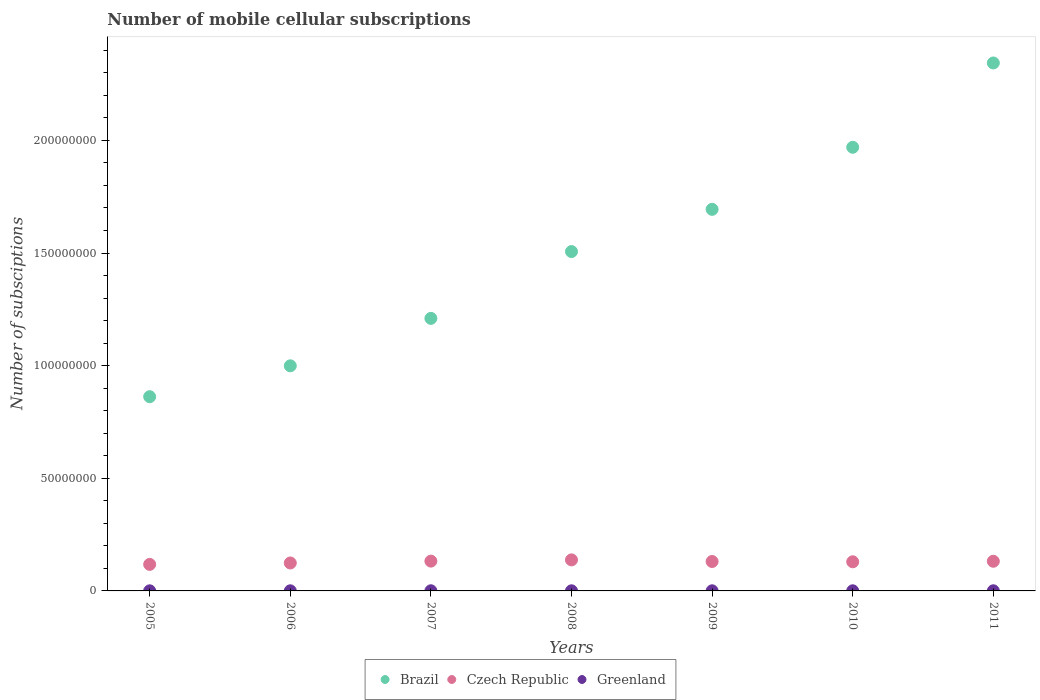How many different coloured dotlines are there?
Keep it short and to the point. 3. What is the number of mobile cellular subscriptions in Czech Republic in 2007?
Keep it short and to the point. 1.32e+07. Across all years, what is the maximum number of mobile cellular subscriptions in Czech Republic?
Your answer should be very brief. 1.38e+07. Across all years, what is the minimum number of mobile cellular subscriptions in Greenland?
Your answer should be compact. 4.65e+04. In which year was the number of mobile cellular subscriptions in Brazil maximum?
Offer a terse response. 2011. What is the total number of mobile cellular subscriptions in Greenland in the graph?
Your answer should be compact. 3.92e+05. What is the difference between the number of mobile cellular subscriptions in Czech Republic in 2006 and that in 2007?
Ensure brevity in your answer.  -8.22e+05. What is the difference between the number of mobile cellular subscriptions in Brazil in 2010 and the number of mobile cellular subscriptions in Czech Republic in 2009?
Your answer should be very brief. 1.84e+08. What is the average number of mobile cellular subscriptions in Czech Republic per year?
Your response must be concise. 1.29e+07. In the year 2007, what is the difference between the number of mobile cellular subscriptions in Greenland and number of mobile cellular subscriptions in Brazil?
Give a very brief answer. -1.21e+08. What is the ratio of the number of mobile cellular subscriptions in Greenland in 2005 to that in 2011?
Provide a short and direct response. 0.79. Is the number of mobile cellular subscriptions in Czech Republic in 2007 less than that in 2010?
Provide a short and direct response. No. What is the difference between the highest and the second highest number of mobile cellular subscriptions in Brazil?
Your answer should be compact. 3.74e+07. What is the difference between the highest and the lowest number of mobile cellular subscriptions in Czech Republic?
Your answer should be very brief. 2.00e+06. Does the number of mobile cellular subscriptions in Czech Republic monotonically increase over the years?
Provide a succinct answer. No. Is the number of mobile cellular subscriptions in Brazil strictly less than the number of mobile cellular subscriptions in Greenland over the years?
Ensure brevity in your answer.  No. How many dotlines are there?
Offer a terse response. 3. How many years are there in the graph?
Provide a short and direct response. 7. Where does the legend appear in the graph?
Offer a terse response. Bottom center. How many legend labels are there?
Provide a succinct answer. 3. What is the title of the graph?
Ensure brevity in your answer.  Number of mobile cellular subscriptions. What is the label or title of the Y-axis?
Provide a succinct answer. Number of subsciptions. What is the Number of subsciptions of Brazil in 2005?
Offer a terse response. 8.62e+07. What is the Number of subsciptions in Czech Republic in 2005?
Keep it short and to the point. 1.18e+07. What is the Number of subsciptions of Greenland in 2005?
Provide a succinct answer. 4.65e+04. What is the Number of subsciptions in Brazil in 2006?
Keep it short and to the point. 9.99e+07. What is the Number of subsciptions of Czech Republic in 2006?
Your answer should be compact. 1.24e+07. What is the Number of subsciptions of Greenland in 2006?
Provide a short and direct response. 5.39e+04. What is the Number of subsciptions of Brazil in 2007?
Offer a very short reply. 1.21e+08. What is the Number of subsciptions of Czech Republic in 2007?
Keep it short and to the point. 1.32e+07. What is the Number of subsciptions of Greenland in 2007?
Keep it short and to the point. 6.64e+04. What is the Number of subsciptions of Brazil in 2008?
Your answer should be compact. 1.51e+08. What is the Number of subsciptions of Czech Republic in 2008?
Make the answer very short. 1.38e+07. What is the Number of subsciptions in Greenland in 2008?
Keep it short and to the point. 5.58e+04. What is the Number of subsciptions in Brazil in 2009?
Your answer should be very brief. 1.69e+08. What is the Number of subsciptions in Czech Republic in 2009?
Ensure brevity in your answer.  1.31e+07. What is the Number of subsciptions of Greenland in 2009?
Your response must be concise. 5.35e+04. What is the Number of subsciptions in Brazil in 2010?
Your response must be concise. 1.97e+08. What is the Number of subsciptions of Czech Republic in 2010?
Your answer should be compact. 1.29e+07. What is the Number of subsciptions in Greenland in 2010?
Offer a very short reply. 5.73e+04. What is the Number of subsciptions of Brazil in 2011?
Give a very brief answer. 2.34e+08. What is the Number of subsciptions in Czech Republic in 2011?
Make the answer very short. 1.32e+07. What is the Number of subsciptions in Greenland in 2011?
Provide a succinct answer. 5.87e+04. Across all years, what is the maximum Number of subsciptions of Brazil?
Your response must be concise. 2.34e+08. Across all years, what is the maximum Number of subsciptions of Czech Republic?
Your answer should be compact. 1.38e+07. Across all years, what is the maximum Number of subsciptions of Greenland?
Give a very brief answer. 6.64e+04. Across all years, what is the minimum Number of subsciptions of Brazil?
Your response must be concise. 8.62e+07. Across all years, what is the minimum Number of subsciptions in Czech Republic?
Your response must be concise. 1.18e+07. Across all years, what is the minimum Number of subsciptions in Greenland?
Your response must be concise. 4.65e+04. What is the total Number of subsciptions in Brazil in the graph?
Offer a very short reply. 1.06e+09. What is the total Number of subsciptions of Czech Republic in the graph?
Give a very brief answer. 9.04e+07. What is the total Number of subsciptions of Greenland in the graph?
Your response must be concise. 3.92e+05. What is the difference between the Number of subsciptions of Brazil in 2005 and that in 2006?
Your answer should be very brief. -1.37e+07. What is the difference between the Number of subsciptions in Czech Republic in 2005 and that in 2006?
Offer a terse response. -6.30e+05. What is the difference between the Number of subsciptions in Greenland in 2005 and that in 2006?
Your response must be concise. -7420. What is the difference between the Number of subsciptions in Brazil in 2005 and that in 2007?
Provide a succinct answer. -3.48e+07. What is the difference between the Number of subsciptions in Czech Republic in 2005 and that in 2007?
Provide a short and direct response. -1.45e+06. What is the difference between the Number of subsciptions in Greenland in 2005 and that in 2007?
Your response must be concise. -1.99e+04. What is the difference between the Number of subsciptions of Brazil in 2005 and that in 2008?
Ensure brevity in your answer.  -6.44e+07. What is the difference between the Number of subsciptions of Czech Republic in 2005 and that in 2008?
Make the answer very short. -2.00e+06. What is the difference between the Number of subsciptions of Greenland in 2005 and that in 2008?
Keep it short and to the point. -9336. What is the difference between the Number of subsciptions of Brazil in 2005 and that in 2009?
Offer a terse response. -8.32e+07. What is the difference between the Number of subsciptions in Czech Republic in 2005 and that in 2009?
Ensure brevity in your answer.  -1.29e+06. What is the difference between the Number of subsciptions of Greenland in 2005 and that in 2009?
Your response must be concise. -6988. What is the difference between the Number of subsciptions in Brazil in 2005 and that in 2010?
Your answer should be very brief. -1.11e+08. What is the difference between the Number of subsciptions in Czech Republic in 2005 and that in 2010?
Make the answer very short. -1.16e+06. What is the difference between the Number of subsciptions in Greenland in 2005 and that in 2010?
Ensure brevity in your answer.  -1.09e+04. What is the difference between the Number of subsciptions in Brazil in 2005 and that in 2011?
Make the answer very short. -1.48e+08. What is the difference between the Number of subsciptions of Czech Republic in 2005 and that in 2011?
Make the answer very short. -1.39e+06. What is the difference between the Number of subsciptions in Greenland in 2005 and that in 2011?
Ensure brevity in your answer.  -1.23e+04. What is the difference between the Number of subsciptions of Brazil in 2006 and that in 2007?
Your answer should be very brief. -2.11e+07. What is the difference between the Number of subsciptions of Czech Republic in 2006 and that in 2007?
Your answer should be compact. -8.22e+05. What is the difference between the Number of subsciptions in Greenland in 2006 and that in 2007?
Offer a very short reply. -1.25e+04. What is the difference between the Number of subsciptions in Brazil in 2006 and that in 2008?
Give a very brief answer. -5.07e+07. What is the difference between the Number of subsciptions in Czech Republic in 2006 and that in 2008?
Give a very brief answer. -1.37e+06. What is the difference between the Number of subsciptions of Greenland in 2006 and that in 2008?
Your answer should be very brief. -1916. What is the difference between the Number of subsciptions of Brazil in 2006 and that in 2009?
Offer a very short reply. -6.95e+07. What is the difference between the Number of subsciptions of Czech Republic in 2006 and that in 2009?
Provide a short and direct response. -6.56e+05. What is the difference between the Number of subsciptions of Greenland in 2006 and that in 2009?
Keep it short and to the point. 432. What is the difference between the Number of subsciptions of Brazil in 2006 and that in 2010?
Keep it short and to the point. -9.70e+07. What is the difference between the Number of subsciptions of Czech Republic in 2006 and that in 2010?
Your answer should be very brief. -5.28e+05. What is the difference between the Number of subsciptions of Greenland in 2006 and that in 2010?
Offer a very short reply. -3449. What is the difference between the Number of subsciptions in Brazil in 2006 and that in 2011?
Give a very brief answer. -1.34e+08. What is the difference between the Number of subsciptions in Czech Republic in 2006 and that in 2011?
Give a very brief answer. -7.62e+05. What is the difference between the Number of subsciptions of Greenland in 2006 and that in 2011?
Offer a very short reply. -4842. What is the difference between the Number of subsciptions of Brazil in 2007 and that in 2008?
Offer a terse response. -2.97e+07. What is the difference between the Number of subsciptions in Czech Republic in 2007 and that in 2008?
Make the answer very short. -5.52e+05. What is the difference between the Number of subsciptions in Greenland in 2007 and that in 2008?
Offer a terse response. 1.06e+04. What is the difference between the Number of subsciptions in Brazil in 2007 and that in 2009?
Provide a succinct answer. -4.84e+07. What is the difference between the Number of subsciptions of Czech Republic in 2007 and that in 2009?
Your response must be concise. 1.66e+05. What is the difference between the Number of subsciptions in Greenland in 2007 and that in 2009?
Your response must be concise. 1.29e+04. What is the difference between the Number of subsciptions of Brazil in 2007 and that in 2010?
Offer a very short reply. -7.59e+07. What is the difference between the Number of subsciptions in Czech Republic in 2007 and that in 2010?
Provide a succinct answer. 2.95e+05. What is the difference between the Number of subsciptions of Greenland in 2007 and that in 2010?
Your response must be concise. 9051. What is the difference between the Number of subsciptions of Brazil in 2007 and that in 2011?
Keep it short and to the point. -1.13e+08. What is the difference between the Number of subsciptions in Czech Republic in 2007 and that in 2011?
Ensure brevity in your answer.  6.09e+04. What is the difference between the Number of subsciptions of Greenland in 2007 and that in 2011?
Offer a very short reply. 7658. What is the difference between the Number of subsciptions in Brazil in 2008 and that in 2009?
Offer a terse response. -1.87e+07. What is the difference between the Number of subsciptions of Czech Republic in 2008 and that in 2009?
Ensure brevity in your answer.  7.18e+05. What is the difference between the Number of subsciptions in Greenland in 2008 and that in 2009?
Offer a terse response. 2348. What is the difference between the Number of subsciptions of Brazil in 2008 and that in 2010?
Offer a terse response. -4.63e+07. What is the difference between the Number of subsciptions of Czech Republic in 2008 and that in 2010?
Provide a short and direct response. 8.46e+05. What is the difference between the Number of subsciptions of Greenland in 2008 and that in 2010?
Your answer should be very brief. -1533. What is the difference between the Number of subsciptions of Brazil in 2008 and that in 2011?
Offer a terse response. -8.37e+07. What is the difference between the Number of subsciptions in Czech Republic in 2008 and that in 2011?
Make the answer very short. 6.12e+05. What is the difference between the Number of subsciptions of Greenland in 2008 and that in 2011?
Give a very brief answer. -2926. What is the difference between the Number of subsciptions of Brazil in 2009 and that in 2010?
Your answer should be very brief. -2.75e+07. What is the difference between the Number of subsciptions in Czech Republic in 2009 and that in 2010?
Your answer should be very brief. 1.29e+05. What is the difference between the Number of subsciptions in Greenland in 2009 and that in 2010?
Your answer should be compact. -3881. What is the difference between the Number of subsciptions of Brazil in 2009 and that in 2011?
Make the answer very short. -6.50e+07. What is the difference between the Number of subsciptions in Czech Republic in 2009 and that in 2011?
Give a very brief answer. -1.05e+05. What is the difference between the Number of subsciptions in Greenland in 2009 and that in 2011?
Ensure brevity in your answer.  -5274. What is the difference between the Number of subsciptions in Brazil in 2010 and that in 2011?
Your response must be concise. -3.74e+07. What is the difference between the Number of subsciptions in Czech Republic in 2010 and that in 2011?
Your answer should be very brief. -2.34e+05. What is the difference between the Number of subsciptions of Greenland in 2010 and that in 2011?
Your answer should be very brief. -1393. What is the difference between the Number of subsciptions of Brazil in 2005 and the Number of subsciptions of Czech Republic in 2006?
Keep it short and to the point. 7.38e+07. What is the difference between the Number of subsciptions in Brazil in 2005 and the Number of subsciptions in Greenland in 2006?
Offer a terse response. 8.62e+07. What is the difference between the Number of subsciptions of Czech Republic in 2005 and the Number of subsciptions of Greenland in 2006?
Your answer should be compact. 1.17e+07. What is the difference between the Number of subsciptions in Brazil in 2005 and the Number of subsciptions in Czech Republic in 2007?
Your answer should be very brief. 7.30e+07. What is the difference between the Number of subsciptions of Brazil in 2005 and the Number of subsciptions of Greenland in 2007?
Make the answer very short. 8.61e+07. What is the difference between the Number of subsciptions in Czech Republic in 2005 and the Number of subsciptions in Greenland in 2007?
Keep it short and to the point. 1.17e+07. What is the difference between the Number of subsciptions in Brazil in 2005 and the Number of subsciptions in Czech Republic in 2008?
Provide a succinct answer. 7.24e+07. What is the difference between the Number of subsciptions in Brazil in 2005 and the Number of subsciptions in Greenland in 2008?
Your answer should be compact. 8.62e+07. What is the difference between the Number of subsciptions in Czech Republic in 2005 and the Number of subsciptions in Greenland in 2008?
Your response must be concise. 1.17e+07. What is the difference between the Number of subsciptions in Brazil in 2005 and the Number of subsciptions in Czech Republic in 2009?
Give a very brief answer. 7.31e+07. What is the difference between the Number of subsciptions of Brazil in 2005 and the Number of subsciptions of Greenland in 2009?
Offer a terse response. 8.62e+07. What is the difference between the Number of subsciptions in Czech Republic in 2005 and the Number of subsciptions in Greenland in 2009?
Ensure brevity in your answer.  1.17e+07. What is the difference between the Number of subsciptions of Brazil in 2005 and the Number of subsciptions of Czech Republic in 2010?
Keep it short and to the point. 7.33e+07. What is the difference between the Number of subsciptions of Brazil in 2005 and the Number of subsciptions of Greenland in 2010?
Your answer should be very brief. 8.62e+07. What is the difference between the Number of subsciptions in Czech Republic in 2005 and the Number of subsciptions in Greenland in 2010?
Make the answer very short. 1.17e+07. What is the difference between the Number of subsciptions of Brazil in 2005 and the Number of subsciptions of Czech Republic in 2011?
Make the answer very short. 7.30e+07. What is the difference between the Number of subsciptions of Brazil in 2005 and the Number of subsciptions of Greenland in 2011?
Give a very brief answer. 8.62e+07. What is the difference between the Number of subsciptions of Czech Republic in 2005 and the Number of subsciptions of Greenland in 2011?
Offer a terse response. 1.17e+07. What is the difference between the Number of subsciptions in Brazil in 2006 and the Number of subsciptions in Czech Republic in 2007?
Your answer should be compact. 8.67e+07. What is the difference between the Number of subsciptions of Brazil in 2006 and the Number of subsciptions of Greenland in 2007?
Offer a very short reply. 9.99e+07. What is the difference between the Number of subsciptions of Czech Republic in 2006 and the Number of subsciptions of Greenland in 2007?
Ensure brevity in your answer.  1.23e+07. What is the difference between the Number of subsciptions in Brazil in 2006 and the Number of subsciptions in Czech Republic in 2008?
Your response must be concise. 8.61e+07. What is the difference between the Number of subsciptions in Brazil in 2006 and the Number of subsciptions in Greenland in 2008?
Your response must be concise. 9.99e+07. What is the difference between the Number of subsciptions of Czech Republic in 2006 and the Number of subsciptions of Greenland in 2008?
Keep it short and to the point. 1.24e+07. What is the difference between the Number of subsciptions of Brazil in 2006 and the Number of subsciptions of Czech Republic in 2009?
Keep it short and to the point. 8.69e+07. What is the difference between the Number of subsciptions of Brazil in 2006 and the Number of subsciptions of Greenland in 2009?
Offer a very short reply. 9.99e+07. What is the difference between the Number of subsciptions in Czech Republic in 2006 and the Number of subsciptions in Greenland in 2009?
Keep it short and to the point. 1.24e+07. What is the difference between the Number of subsciptions of Brazil in 2006 and the Number of subsciptions of Czech Republic in 2010?
Provide a short and direct response. 8.70e+07. What is the difference between the Number of subsciptions in Brazil in 2006 and the Number of subsciptions in Greenland in 2010?
Offer a terse response. 9.99e+07. What is the difference between the Number of subsciptions in Czech Republic in 2006 and the Number of subsciptions in Greenland in 2010?
Ensure brevity in your answer.  1.23e+07. What is the difference between the Number of subsciptions in Brazil in 2006 and the Number of subsciptions in Czech Republic in 2011?
Your answer should be very brief. 8.68e+07. What is the difference between the Number of subsciptions of Brazil in 2006 and the Number of subsciptions of Greenland in 2011?
Ensure brevity in your answer.  9.99e+07. What is the difference between the Number of subsciptions of Czech Republic in 2006 and the Number of subsciptions of Greenland in 2011?
Provide a short and direct response. 1.23e+07. What is the difference between the Number of subsciptions of Brazil in 2007 and the Number of subsciptions of Czech Republic in 2008?
Offer a terse response. 1.07e+08. What is the difference between the Number of subsciptions in Brazil in 2007 and the Number of subsciptions in Greenland in 2008?
Your answer should be compact. 1.21e+08. What is the difference between the Number of subsciptions in Czech Republic in 2007 and the Number of subsciptions in Greenland in 2008?
Keep it short and to the point. 1.32e+07. What is the difference between the Number of subsciptions in Brazil in 2007 and the Number of subsciptions in Czech Republic in 2009?
Your answer should be compact. 1.08e+08. What is the difference between the Number of subsciptions of Brazil in 2007 and the Number of subsciptions of Greenland in 2009?
Your answer should be compact. 1.21e+08. What is the difference between the Number of subsciptions in Czech Republic in 2007 and the Number of subsciptions in Greenland in 2009?
Your answer should be compact. 1.32e+07. What is the difference between the Number of subsciptions of Brazil in 2007 and the Number of subsciptions of Czech Republic in 2010?
Offer a terse response. 1.08e+08. What is the difference between the Number of subsciptions in Brazil in 2007 and the Number of subsciptions in Greenland in 2010?
Provide a succinct answer. 1.21e+08. What is the difference between the Number of subsciptions in Czech Republic in 2007 and the Number of subsciptions in Greenland in 2010?
Offer a terse response. 1.32e+07. What is the difference between the Number of subsciptions of Brazil in 2007 and the Number of subsciptions of Czech Republic in 2011?
Ensure brevity in your answer.  1.08e+08. What is the difference between the Number of subsciptions of Brazil in 2007 and the Number of subsciptions of Greenland in 2011?
Give a very brief answer. 1.21e+08. What is the difference between the Number of subsciptions of Czech Republic in 2007 and the Number of subsciptions of Greenland in 2011?
Keep it short and to the point. 1.32e+07. What is the difference between the Number of subsciptions in Brazil in 2008 and the Number of subsciptions in Czech Republic in 2009?
Your answer should be very brief. 1.38e+08. What is the difference between the Number of subsciptions in Brazil in 2008 and the Number of subsciptions in Greenland in 2009?
Make the answer very short. 1.51e+08. What is the difference between the Number of subsciptions in Czech Republic in 2008 and the Number of subsciptions in Greenland in 2009?
Your answer should be compact. 1.37e+07. What is the difference between the Number of subsciptions in Brazil in 2008 and the Number of subsciptions in Czech Republic in 2010?
Offer a very short reply. 1.38e+08. What is the difference between the Number of subsciptions in Brazil in 2008 and the Number of subsciptions in Greenland in 2010?
Keep it short and to the point. 1.51e+08. What is the difference between the Number of subsciptions in Czech Republic in 2008 and the Number of subsciptions in Greenland in 2010?
Provide a succinct answer. 1.37e+07. What is the difference between the Number of subsciptions in Brazil in 2008 and the Number of subsciptions in Czech Republic in 2011?
Provide a short and direct response. 1.37e+08. What is the difference between the Number of subsciptions of Brazil in 2008 and the Number of subsciptions of Greenland in 2011?
Provide a short and direct response. 1.51e+08. What is the difference between the Number of subsciptions in Czech Republic in 2008 and the Number of subsciptions in Greenland in 2011?
Ensure brevity in your answer.  1.37e+07. What is the difference between the Number of subsciptions of Brazil in 2009 and the Number of subsciptions of Czech Republic in 2010?
Keep it short and to the point. 1.56e+08. What is the difference between the Number of subsciptions of Brazil in 2009 and the Number of subsciptions of Greenland in 2010?
Your response must be concise. 1.69e+08. What is the difference between the Number of subsciptions in Czech Republic in 2009 and the Number of subsciptions in Greenland in 2010?
Offer a terse response. 1.30e+07. What is the difference between the Number of subsciptions in Brazil in 2009 and the Number of subsciptions in Czech Republic in 2011?
Your answer should be very brief. 1.56e+08. What is the difference between the Number of subsciptions in Brazil in 2009 and the Number of subsciptions in Greenland in 2011?
Keep it short and to the point. 1.69e+08. What is the difference between the Number of subsciptions of Czech Republic in 2009 and the Number of subsciptions of Greenland in 2011?
Provide a short and direct response. 1.30e+07. What is the difference between the Number of subsciptions of Brazil in 2010 and the Number of subsciptions of Czech Republic in 2011?
Keep it short and to the point. 1.84e+08. What is the difference between the Number of subsciptions in Brazil in 2010 and the Number of subsciptions in Greenland in 2011?
Your answer should be compact. 1.97e+08. What is the difference between the Number of subsciptions of Czech Republic in 2010 and the Number of subsciptions of Greenland in 2011?
Your response must be concise. 1.29e+07. What is the average Number of subsciptions in Brazil per year?
Offer a terse response. 1.51e+08. What is the average Number of subsciptions in Czech Republic per year?
Your answer should be compact. 1.29e+07. What is the average Number of subsciptions in Greenland per year?
Your answer should be compact. 5.60e+04. In the year 2005, what is the difference between the Number of subsciptions of Brazil and Number of subsciptions of Czech Republic?
Your answer should be compact. 7.44e+07. In the year 2005, what is the difference between the Number of subsciptions of Brazil and Number of subsciptions of Greenland?
Give a very brief answer. 8.62e+07. In the year 2005, what is the difference between the Number of subsciptions of Czech Republic and Number of subsciptions of Greenland?
Provide a short and direct response. 1.17e+07. In the year 2006, what is the difference between the Number of subsciptions in Brazil and Number of subsciptions in Czech Republic?
Offer a terse response. 8.75e+07. In the year 2006, what is the difference between the Number of subsciptions of Brazil and Number of subsciptions of Greenland?
Your answer should be very brief. 9.99e+07. In the year 2006, what is the difference between the Number of subsciptions of Czech Republic and Number of subsciptions of Greenland?
Keep it short and to the point. 1.24e+07. In the year 2007, what is the difference between the Number of subsciptions of Brazil and Number of subsciptions of Czech Republic?
Offer a terse response. 1.08e+08. In the year 2007, what is the difference between the Number of subsciptions in Brazil and Number of subsciptions in Greenland?
Keep it short and to the point. 1.21e+08. In the year 2007, what is the difference between the Number of subsciptions in Czech Republic and Number of subsciptions in Greenland?
Provide a short and direct response. 1.32e+07. In the year 2008, what is the difference between the Number of subsciptions in Brazil and Number of subsciptions in Czech Republic?
Your response must be concise. 1.37e+08. In the year 2008, what is the difference between the Number of subsciptions of Brazil and Number of subsciptions of Greenland?
Offer a terse response. 1.51e+08. In the year 2008, what is the difference between the Number of subsciptions of Czech Republic and Number of subsciptions of Greenland?
Your answer should be very brief. 1.37e+07. In the year 2009, what is the difference between the Number of subsciptions of Brazil and Number of subsciptions of Czech Republic?
Keep it short and to the point. 1.56e+08. In the year 2009, what is the difference between the Number of subsciptions in Brazil and Number of subsciptions in Greenland?
Give a very brief answer. 1.69e+08. In the year 2009, what is the difference between the Number of subsciptions of Czech Republic and Number of subsciptions of Greenland?
Provide a succinct answer. 1.30e+07. In the year 2010, what is the difference between the Number of subsciptions in Brazil and Number of subsciptions in Czech Republic?
Keep it short and to the point. 1.84e+08. In the year 2010, what is the difference between the Number of subsciptions in Brazil and Number of subsciptions in Greenland?
Give a very brief answer. 1.97e+08. In the year 2010, what is the difference between the Number of subsciptions of Czech Republic and Number of subsciptions of Greenland?
Offer a very short reply. 1.29e+07. In the year 2011, what is the difference between the Number of subsciptions in Brazil and Number of subsciptions in Czech Republic?
Ensure brevity in your answer.  2.21e+08. In the year 2011, what is the difference between the Number of subsciptions of Brazil and Number of subsciptions of Greenland?
Your response must be concise. 2.34e+08. In the year 2011, what is the difference between the Number of subsciptions in Czech Republic and Number of subsciptions in Greenland?
Provide a short and direct response. 1.31e+07. What is the ratio of the Number of subsciptions in Brazil in 2005 to that in 2006?
Offer a very short reply. 0.86. What is the ratio of the Number of subsciptions in Czech Republic in 2005 to that in 2006?
Your answer should be compact. 0.95. What is the ratio of the Number of subsciptions of Greenland in 2005 to that in 2006?
Offer a terse response. 0.86. What is the ratio of the Number of subsciptions of Brazil in 2005 to that in 2007?
Keep it short and to the point. 0.71. What is the ratio of the Number of subsciptions of Czech Republic in 2005 to that in 2007?
Your answer should be very brief. 0.89. What is the ratio of the Number of subsciptions in Greenland in 2005 to that in 2007?
Provide a succinct answer. 0.7. What is the ratio of the Number of subsciptions of Brazil in 2005 to that in 2008?
Provide a succinct answer. 0.57. What is the ratio of the Number of subsciptions in Czech Republic in 2005 to that in 2008?
Provide a short and direct response. 0.85. What is the ratio of the Number of subsciptions of Greenland in 2005 to that in 2008?
Offer a terse response. 0.83. What is the ratio of the Number of subsciptions of Brazil in 2005 to that in 2009?
Your answer should be very brief. 0.51. What is the ratio of the Number of subsciptions of Czech Republic in 2005 to that in 2009?
Your answer should be compact. 0.9. What is the ratio of the Number of subsciptions of Greenland in 2005 to that in 2009?
Your answer should be very brief. 0.87. What is the ratio of the Number of subsciptions of Brazil in 2005 to that in 2010?
Your answer should be compact. 0.44. What is the ratio of the Number of subsciptions of Czech Republic in 2005 to that in 2010?
Your answer should be compact. 0.91. What is the ratio of the Number of subsciptions of Greenland in 2005 to that in 2010?
Your response must be concise. 0.81. What is the ratio of the Number of subsciptions in Brazil in 2005 to that in 2011?
Make the answer very short. 0.37. What is the ratio of the Number of subsciptions of Czech Republic in 2005 to that in 2011?
Make the answer very short. 0.89. What is the ratio of the Number of subsciptions in Greenland in 2005 to that in 2011?
Make the answer very short. 0.79. What is the ratio of the Number of subsciptions of Brazil in 2006 to that in 2007?
Make the answer very short. 0.83. What is the ratio of the Number of subsciptions of Czech Republic in 2006 to that in 2007?
Offer a terse response. 0.94. What is the ratio of the Number of subsciptions in Greenland in 2006 to that in 2007?
Offer a very short reply. 0.81. What is the ratio of the Number of subsciptions of Brazil in 2006 to that in 2008?
Give a very brief answer. 0.66. What is the ratio of the Number of subsciptions of Czech Republic in 2006 to that in 2008?
Provide a short and direct response. 0.9. What is the ratio of the Number of subsciptions in Greenland in 2006 to that in 2008?
Your response must be concise. 0.97. What is the ratio of the Number of subsciptions of Brazil in 2006 to that in 2009?
Offer a terse response. 0.59. What is the ratio of the Number of subsciptions of Czech Republic in 2006 to that in 2009?
Provide a succinct answer. 0.95. What is the ratio of the Number of subsciptions in Greenland in 2006 to that in 2009?
Provide a succinct answer. 1.01. What is the ratio of the Number of subsciptions in Brazil in 2006 to that in 2010?
Keep it short and to the point. 0.51. What is the ratio of the Number of subsciptions of Czech Republic in 2006 to that in 2010?
Provide a succinct answer. 0.96. What is the ratio of the Number of subsciptions of Greenland in 2006 to that in 2010?
Provide a short and direct response. 0.94. What is the ratio of the Number of subsciptions in Brazil in 2006 to that in 2011?
Offer a very short reply. 0.43. What is the ratio of the Number of subsciptions in Czech Republic in 2006 to that in 2011?
Keep it short and to the point. 0.94. What is the ratio of the Number of subsciptions of Greenland in 2006 to that in 2011?
Offer a very short reply. 0.92. What is the ratio of the Number of subsciptions of Brazil in 2007 to that in 2008?
Ensure brevity in your answer.  0.8. What is the ratio of the Number of subsciptions of Czech Republic in 2007 to that in 2008?
Your response must be concise. 0.96. What is the ratio of the Number of subsciptions of Greenland in 2007 to that in 2008?
Provide a succinct answer. 1.19. What is the ratio of the Number of subsciptions in Brazil in 2007 to that in 2009?
Offer a terse response. 0.71. What is the ratio of the Number of subsciptions in Czech Republic in 2007 to that in 2009?
Your answer should be compact. 1.01. What is the ratio of the Number of subsciptions of Greenland in 2007 to that in 2009?
Your response must be concise. 1.24. What is the ratio of the Number of subsciptions in Brazil in 2007 to that in 2010?
Provide a short and direct response. 0.61. What is the ratio of the Number of subsciptions in Czech Republic in 2007 to that in 2010?
Keep it short and to the point. 1.02. What is the ratio of the Number of subsciptions in Greenland in 2007 to that in 2010?
Provide a short and direct response. 1.16. What is the ratio of the Number of subsciptions of Brazil in 2007 to that in 2011?
Your answer should be very brief. 0.52. What is the ratio of the Number of subsciptions in Czech Republic in 2007 to that in 2011?
Provide a succinct answer. 1. What is the ratio of the Number of subsciptions in Greenland in 2007 to that in 2011?
Ensure brevity in your answer.  1.13. What is the ratio of the Number of subsciptions of Brazil in 2008 to that in 2009?
Your answer should be compact. 0.89. What is the ratio of the Number of subsciptions in Czech Republic in 2008 to that in 2009?
Keep it short and to the point. 1.05. What is the ratio of the Number of subsciptions of Greenland in 2008 to that in 2009?
Keep it short and to the point. 1.04. What is the ratio of the Number of subsciptions in Brazil in 2008 to that in 2010?
Provide a succinct answer. 0.76. What is the ratio of the Number of subsciptions in Czech Republic in 2008 to that in 2010?
Provide a short and direct response. 1.07. What is the ratio of the Number of subsciptions in Greenland in 2008 to that in 2010?
Your response must be concise. 0.97. What is the ratio of the Number of subsciptions of Brazil in 2008 to that in 2011?
Your response must be concise. 0.64. What is the ratio of the Number of subsciptions of Czech Republic in 2008 to that in 2011?
Provide a succinct answer. 1.05. What is the ratio of the Number of subsciptions of Greenland in 2008 to that in 2011?
Provide a succinct answer. 0.95. What is the ratio of the Number of subsciptions of Brazil in 2009 to that in 2010?
Your answer should be very brief. 0.86. What is the ratio of the Number of subsciptions in Czech Republic in 2009 to that in 2010?
Keep it short and to the point. 1.01. What is the ratio of the Number of subsciptions of Greenland in 2009 to that in 2010?
Your answer should be very brief. 0.93. What is the ratio of the Number of subsciptions of Brazil in 2009 to that in 2011?
Keep it short and to the point. 0.72. What is the ratio of the Number of subsciptions of Greenland in 2009 to that in 2011?
Ensure brevity in your answer.  0.91. What is the ratio of the Number of subsciptions of Brazil in 2010 to that in 2011?
Make the answer very short. 0.84. What is the ratio of the Number of subsciptions of Czech Republic in 2010 to that in 2011?
Offer a terse response. 0.98. What is the ratio of the Number of subsciptions of Greenland in 2010 to that in 2011?
Your response must be concise. 0.98. What is the difference between the highest and the second highest Number of subsciptions in Brazil?
Your answer should be very brief. 3.74e+07. What is the difference between the highest and the second highest Number of subsciptions of Czech Republic?
Offer a terse response. 5.52e+05. What is the difference between the highest and the second highest Number of subsciptions in Greenland?
Your answer should be very brief. 7658. What is the difference between the highest and the lowest Number of subsciptions in Brazil?
Your answer should be compact. 1.48e+08. What is the difference between the highest and the lowest Number of subsciptions of Czech Republic?
Keep it short and to the point. 2.00e+06. What is the difference between the highest and the lowest Number of subsciptions of Greenland?
Your response must be concise. 1.99e+04. 